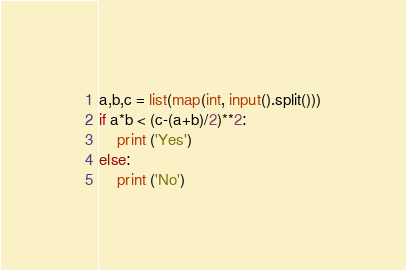<code> <loc_0><loc_0><loc_500><loc_500><_Python_>a,b,c = list(map(int, input().split()))
if a*b < (c-(a+b)/2)**2:
    print ('Yes')
else:
    print ('No')</code> 